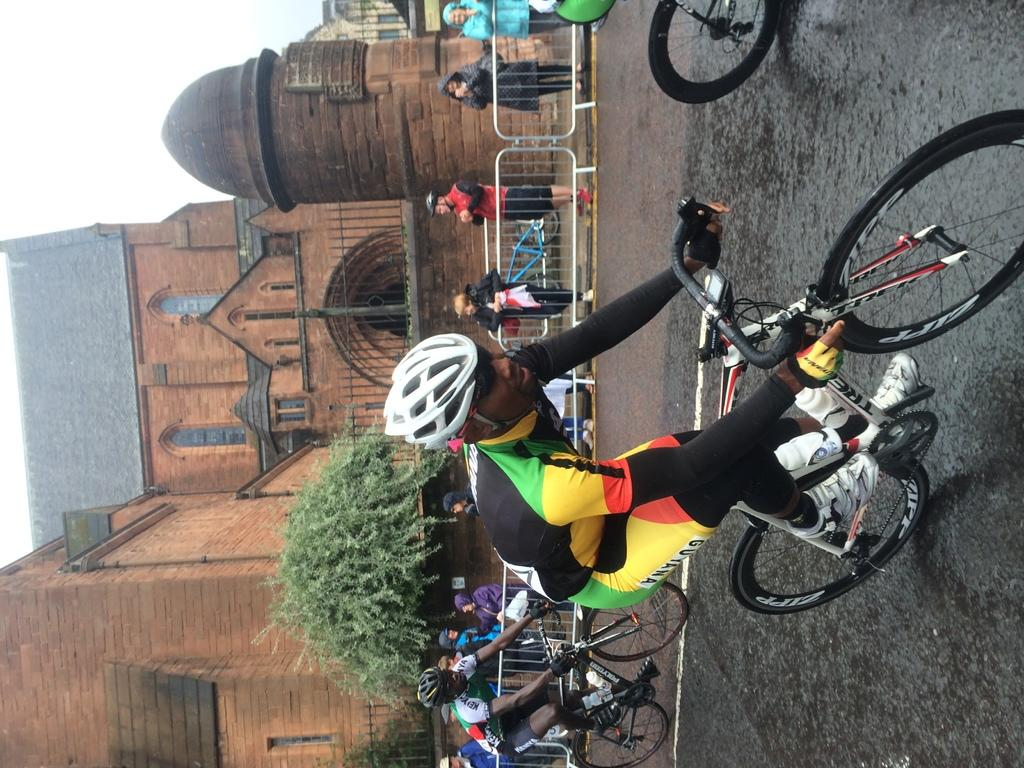What is happening in the image involving the group of people? Some people are riding bicycles on the road, while others are standing behind a fence. Can you describe the setting of the image? There are trees and houses visible in the background of the image. What type of transportation is being used by some of the people in the image? Some people are riding bicycles on the road. What is the name of the quilt that is being used as a background prop in the image? There is no quilt present in the image, so it cannot be named. 